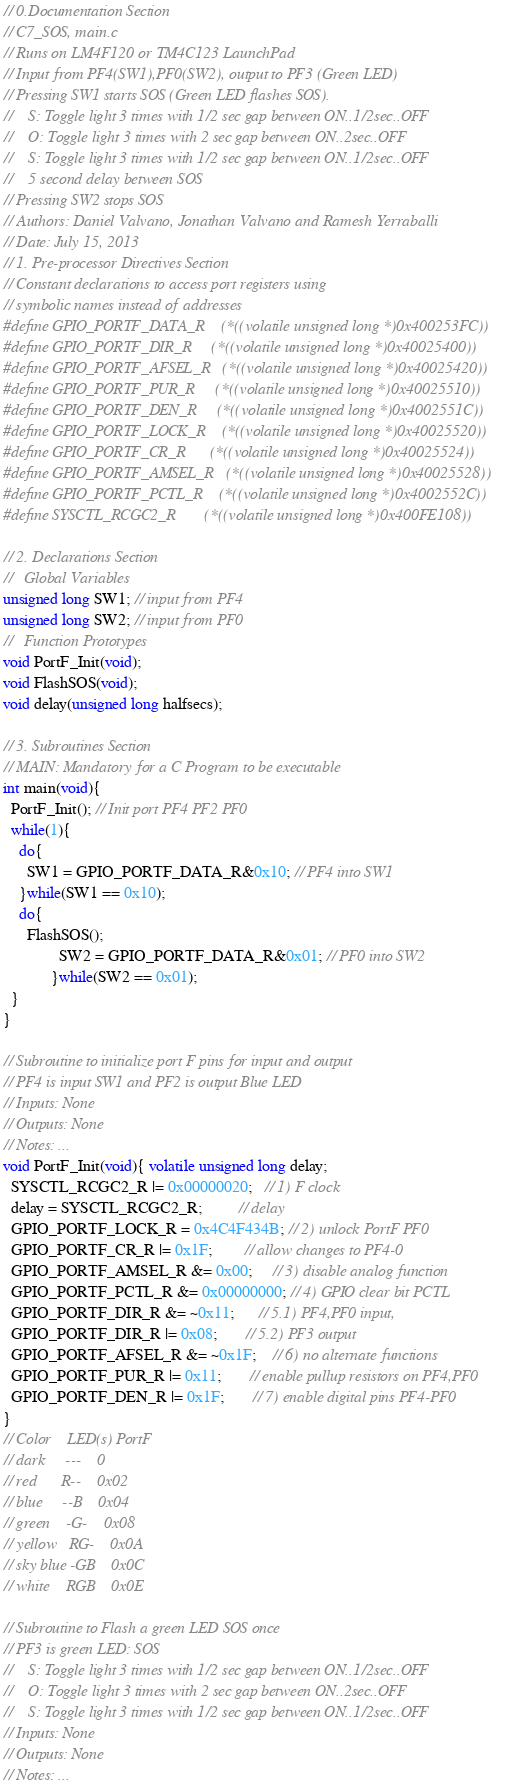<code> <loc_0><loc_0><loc_500><loc_500><_C_>// 0.Documentation Section 
// C7_SOS, main.c
// Runs on LM4F120 or TM4C123 LaunchPad
// Input from PF4(SW1),PF0(SW2), output to PF3 (Green LED)
// Pressing SW1 starts SOS (Green LED flashes SOS).
//    S: Toggle light 3 times with 1/2 sec gap between ON..1/2sec..OFF
//    O: Toggle light 3 times with 2 sec gap between ON..2sec..OFF
//    S: Toggle light 3 times with 1/2 sec gap between ON..1/2sec..OFF
//    5 second delay between SOS
// Pressing SW2 stops SOS
// Authors: Daniel Valvano, Jonathan Valvano and Ramesh Yerraballi
// Date: July 15, 2013
// 1. Pre-processor Directives Section
// Constant declarations to access port registers using 
// symbolic names instead of addresses
#define GPIO_PORTF_DATA_R    (*((volatile unsigned long *)0x400253FC))
#define GPIO_PORTF_DIR_R     (*((volatile unsigned long *)0x40025400))
#define GPIO_PORTF_AFSEL_R   (*((volatile unsigned long *)0x40025420))
#define GPIO_PORTF_PUR_R     (*((volatile unsigned long *)0x40025510))
#define GPIO_PORTF_DEN_R     (*((volatile unsigned long *)0x4002551C))
#define GPIO_PORTF_LOCK_R    (*((volatile unsigned long *)0x40025520))
#define GPIO_PORTF_CR_R      (*((volatile unsigned long *)0x40025524))
#define GPIO_PORTF_AMSEL_R   (*((volatile unsigned long *)0x40025528))
#define GPIO_PORTF_PCTL_R    (*((volatile unsigned long *)0x4002552C))
#define SYSCTL_RCGC2_R       (*((volatile unsigned long *)0x400FE108))
 
// 2. Declarations Section
//   Global Variables
unsigned long SW1; // input from PF4
unsigned long SW2; // input from PF0
//   Function Prototypes
void PortF_Init(void);
void FlashSOS(void);
void delay(unsigned long halfsecs);
 
// 3. Subroutines Section
// MAIN: Mandatory for a C Program to be executable
int main(void){
  PortF_Init(); // Init port PF4 PF2 PF0    
  while(1){
    do{
      SW1 = GPIO_PORTF_DATA_R&0x10; // PF4 into SW1
    }while(SW1 == 0x10);
    do{
      FlashSOS();
              SW2 = GPIO_PORTF_DATA_R&0x01; // PF0 into SW2
            }while(SW2 == 0x01);
  }
}
 
// Subroutine to initialize port F pins for input and output
// PF4 is input SW1 and PF2 is output Blue LED
// Inputs: None
// Outputs: None
// Notes: ...
void PortF_Init(void){ volatile unsigned long delay;
  SYSCTL_RCGC2_R |= 0x00000020;   // 1) F clock
  delay = SYSCTL_RCGC2_R;         // delay   
  GPIO_PORTF_LOCK_R = 0x4C4F434B; // 2) unlock PortF PF0  
  GPIO_PORTF_CR_R |= 0x1F;        // allow changes to PF4-0       
  GPIO_PORTF_AMSEL_R &= 0x00;     // 3) disable analog function
  GPIO_PORTF_PCTL_R &= 0x00000000; // 4) GPIO clear bit PCTL  
  GPIO_PORTF_DIR_R &= ~0x11;      // 5.1) PF4,PF0 input, 
  GPIO_PORTF_DIR_R |= 0x08;       // 5.2) PF3 output 
  GPIO_PORTF_AFSEL_R &= ~0x1F;    // 6) no alternate functions
  GPIO_PORTF_PUR_R |= 0x11;       // enable pullup resistors on PF4,PF0       
  GPIO_PORTF_DEN_R |= 0x1F;       // 7) enable digital pins PF4-PF0        
}
// Color    LED(s) PortF
// dark     ---    0
// red      R--    0x02
// blue     --B    0x04
// green    -G-    0x08
// yellow   RG-    0x0A
// sky blue -GB    0x0C
// white    RGB    0x0E
 
// Subroutine to Flash a green LED SOS once
// PF3 is green LED: SOS 
//    S: Toggle light 3 times with 1/2 sec gap between ON..1/2sec..OFF
//    O: Toggle light 3 times with 2 sec gap between ON..2sec..OFF
//    S: Toggle light 3 times with 1/2 sec gap between ON..1/2sec..OFF
// Inputs: None
// Outputs: None
// Notes: ...</code> 